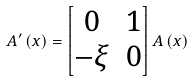Convert formula to latex. <formula><loc_0><loc_0><loc_500><loc_500>A ^ { \prime } \left ( x \right ) = \begin{bmatrix} 0 & 1 \\ - \xi & 0 \end{bmatrix} A \left ( x \right )</formula> 